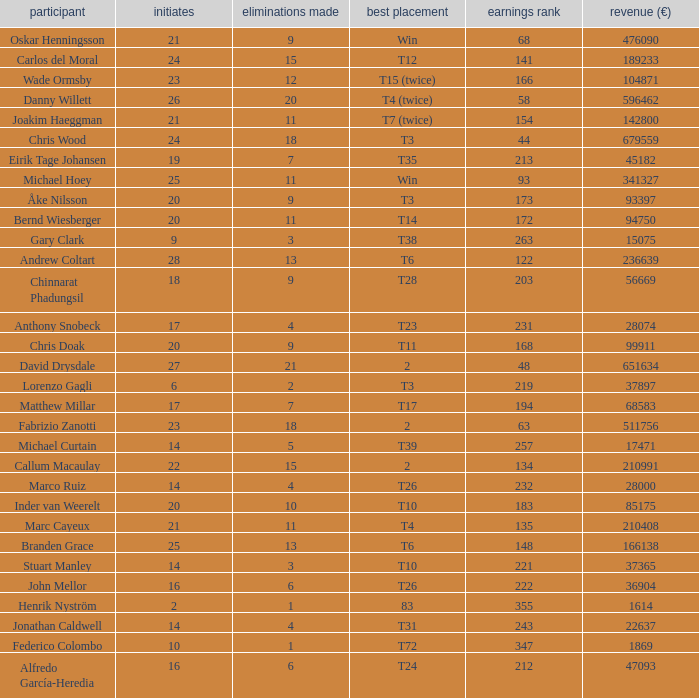How many earnings values are associated with players who had a best finish of T38? 1.0. 